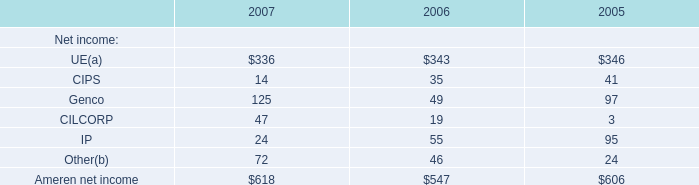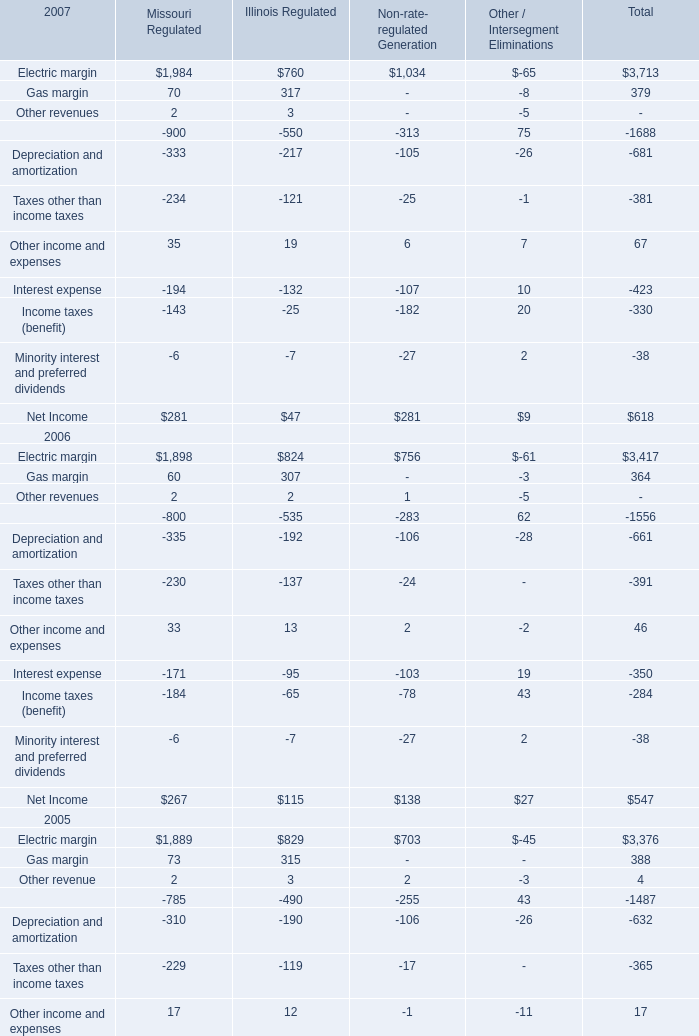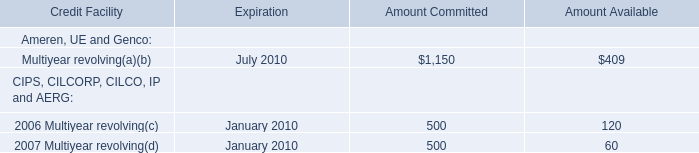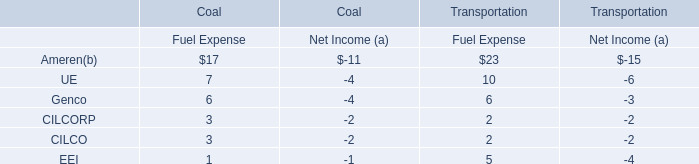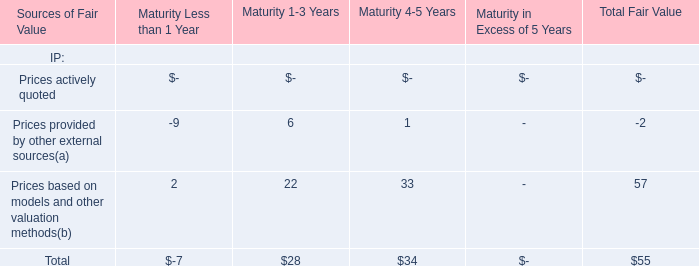In which year is Electric margin of Total positive? 
Answer: 2007. 